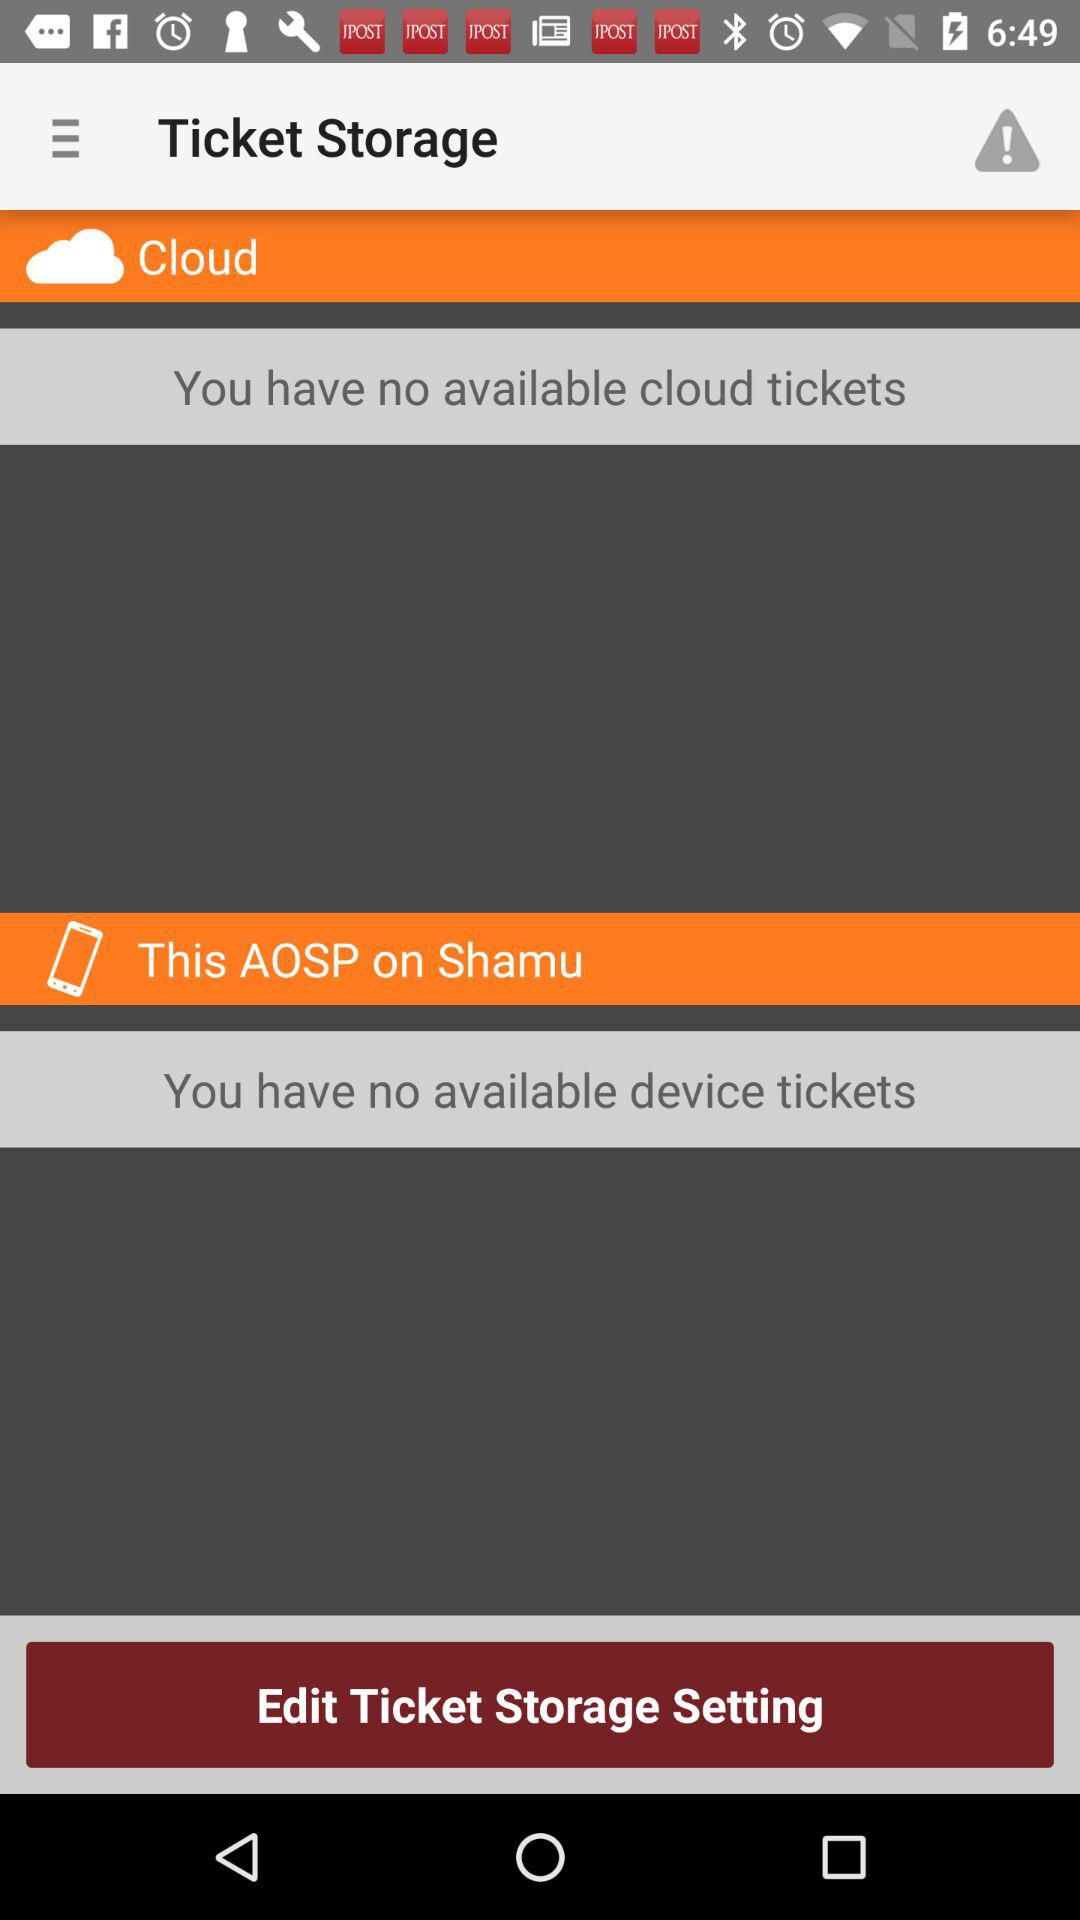How many tickets are available in total?
Answer the question using a single word or phrase. 0 